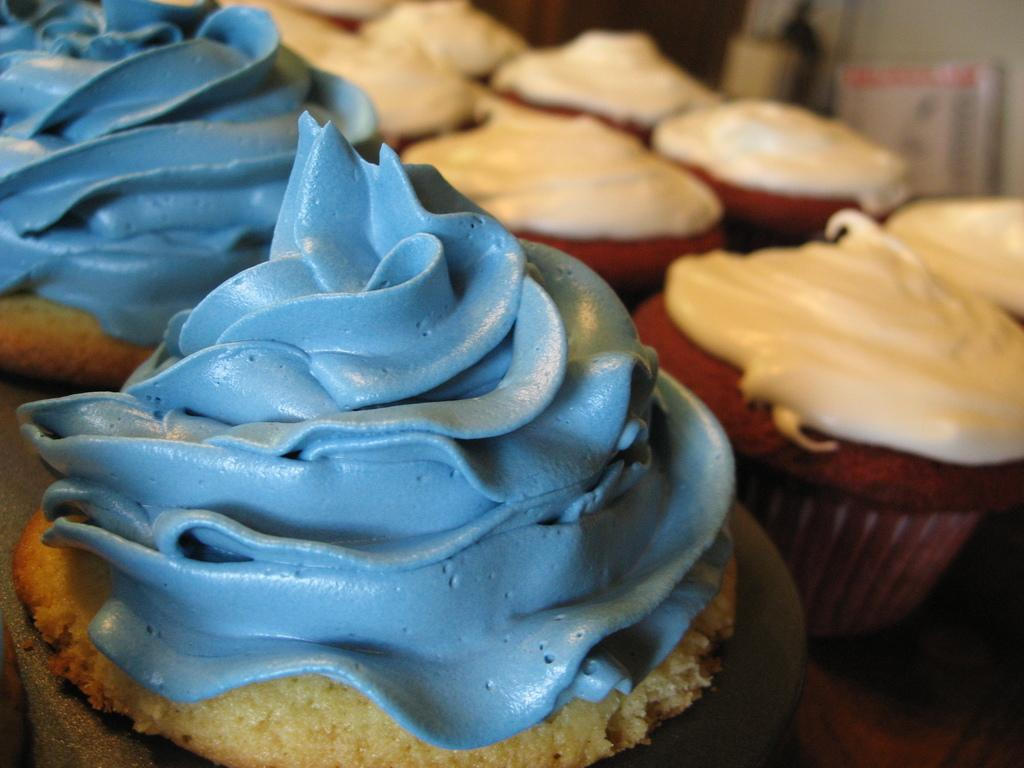What type of food is visible in the image? There are cupcakes in the image. Where are the cupcakes located? The cupcakes are placed on a table. What can be seen in the background of the image? There is a wall and a white color board in the background of the image. What decision was made by the cupcakes in the image? There is no indication in the image that the cupcakes made any decisions, as they are inanimate objects. 